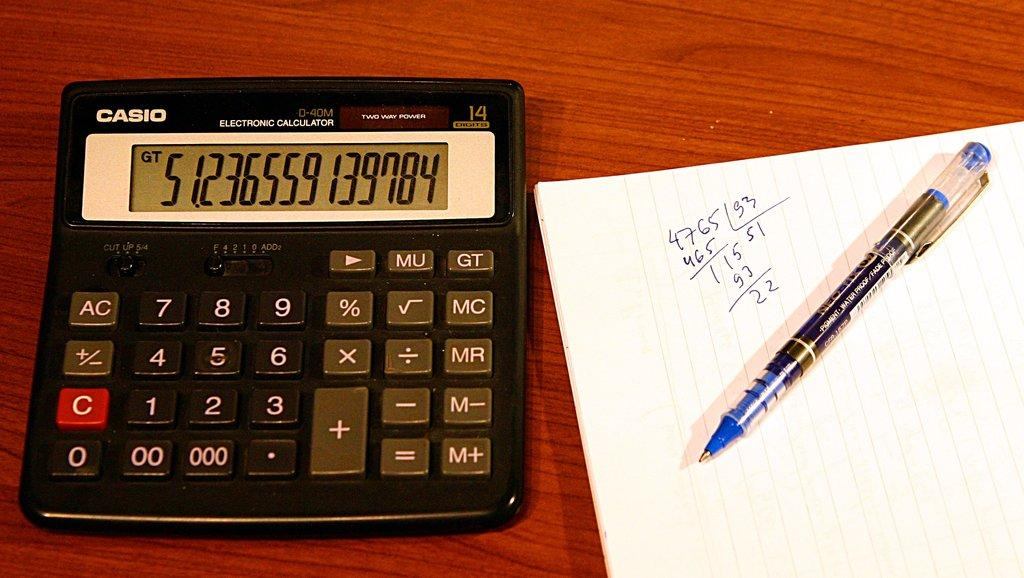<image>
Present a compact description of the photo's key features. a calculator with the number 5 on it on a brown table 